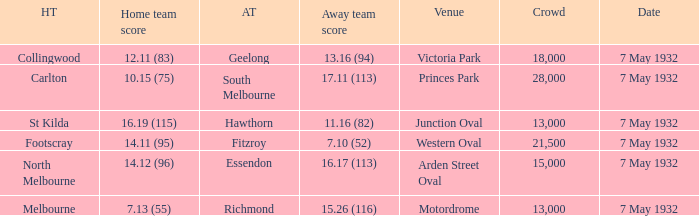What is the away team with a Crowd greater than 13,000, and a Home team score of 12.11 (83)? Geelong. Could you help me parse every detail presented in this table? {'header': ['HT', 'Home team score', 'AT', 'Away team score', 'Venue', 'Crowd', 'Date'], 'rows': [['Collingwood', '12.11 (83)', 'Geelong', '13.16 (94)', 'Victoria Park', '18,000', '7 May 1932'], ['Carlton', '10.15 (75)', 'South Melbourne', '17.11 (113)', 'Princes Park', '28,000', '7 May 1932'], ['St Kilda', '16.19 (115)', 'Hawthorn', '11.16 (82)', 'Junction Oval', '13,000', '7 May 1932'], ['Footscray', '14.11 (95)', 'Fitzroy', '7.10 (52)', 'Western Oval', '21,500', '7 May 1932'], ['North Melbourne', '14.12 (96)', 'Essendon', '16.17 (113)', 'Arden Street Oval', '15,000', '7 May 1932'], ['Melbourne', '7.13 (55)', 'Richmond', '15.26 (116)', 'Motordrome', '13,000', '7 May 1932']]} 